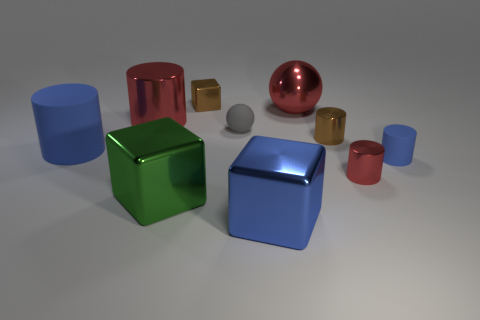Are there any large red objects made of the same material as the green object? Yes, there is a large red cylindrical object to the left that appears to be made of a similar shiny material as the green cube in the foreground. 